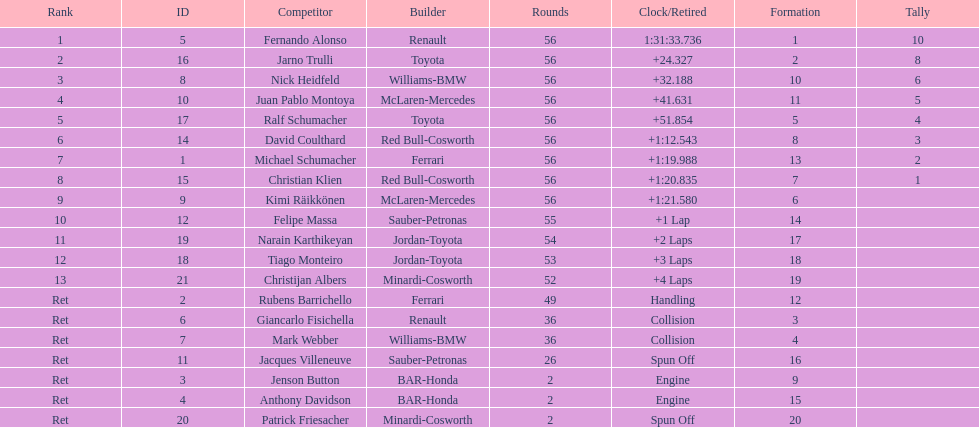What driver finished first? Fernando Alonso. Would you mind parsing the complete table? {'header': ['Rank', 'ID', 'Competitor', 'Builder', 'Rounds', 'Clock/Retired', 'Formation', 'Tally'], 'rows': [['1', '5', 'Fernando Alonso', 'Renault', '56', '1:31:33.736', '1', '10'], ['2', '16', 'Jarno Trulli', 'Toyota', '56', '+24.327', '2', '8'], ['3', '8', 'Nick Heidfeld', 'Williams-BMW', '56', '+32.188', '10', '6'], ['4', '10', 'Juan Pablo Montoya', 'McLaren-Mercedes', '56', '+41.631', '11', '5'], ['5', '17', 'Ralf Schumacher', 'Toyota', '56', '+51.854', '5', '4'], ['6', '14', 'David Coulthard', 'Red Bull-Cosworth', '56', '+1:12.543', '8', '3'], ['7', '1', 'Michael Schumacher', 'Ferrari', '56', '+1:19.988', '13', '2'], ['8', '15', 'Christian Klien', 'Red Bull-Cosworth', '56', '+1:20.835', '7', '1'], ['9', '9', 'Kimi Räikkönen', 'McLaren-Mercedes', '56', '+1:21.580', '6', ''], ['10', '12', 'Felipe Massa', 'Sauber-Petronas', '55', '+1 Lap', '14', ''], ['11', '19', 'Narain Karthikeyan', 'Jordan-Toyota', '54', '+2 Laps', '17', ''], ['12', '18', 'Tiago Monteiro', 'Jordan-Toyota', '53', '+3 Laps', '18', ''], ['13', '21', 'Christijan Albers', 'Minardi-Cosworth', '52', '+4 Laps', '19', ''], ['Ret', '2', 'Rubens Barrichello', 'Ferrari', '49', 'Handling', '12', ''], ['Ret', '6', 'Giancarlo Fisichella', 'Renault', '36', 'Collision', '3', ''], ['Ret', '7', 'Mark Webber', 'Williams-BMW', '36', 'Collision', '4', ''], ['Ret', '11', 'Jacques Villeneuve', 'Sauber-Petronas', '26', 'Spun Off', '16', ''], ['Ret', '3', 'Jenson Button', 'BAR-Honda', '2', 'Engine', '9', ''], ['Ret', '4', 'Anthony Davidson', 'BAR-Honda', '2', 'Engine', '15', ''], ['Ret', '20', 'Patrick Friesacher', 'Minardi-Cosworth', '2', 'Spun Off', '20', '']]} 